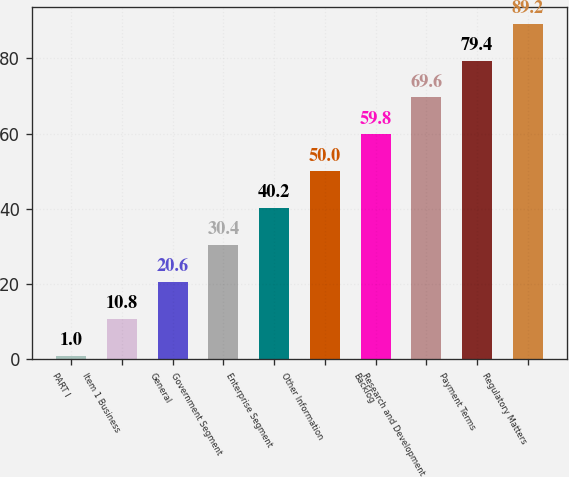Convert chart to OTSL. <chart><loc_0><loc_0><loc_500><loc_500><bar_chart><fcel>PART I<fcel>Item 1 Business<fcel>General<fcel>Government Segment<fcel>Enterprise Segment<fcel>Other Information<fcel>Backlog<fcel>Research and Development<fcel>Payment Terms<fcel>Regulatory Matters<nl><fcel>1<fcel>10.8<fcel>20.6<fcel>30.4<fcel>40.2<fcel>50<fcel>59.8<fcel>69.6<fcel>79.4<fcel>89.2<nl></chart> 